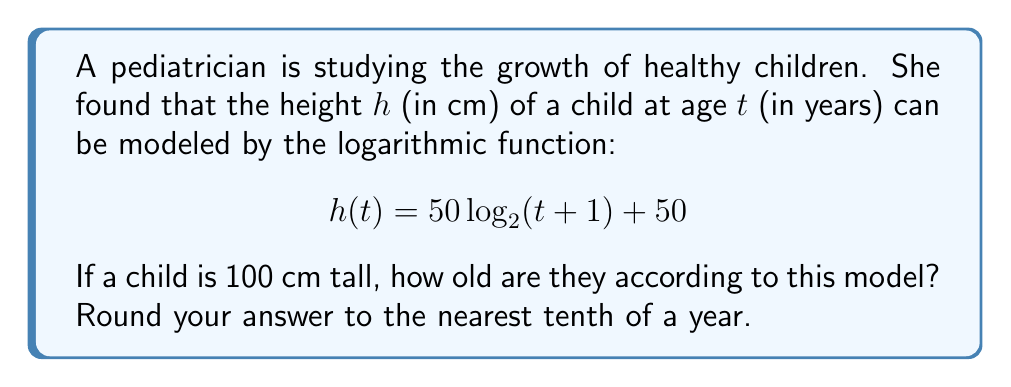Can you answer this question? Let's solve this step-by-step:

1) We're given that $h(t) = 50 \log_2(t+1) + 50$ and we want to find $t$ when $h(t) = 100$.

2) Substitute $h(t) = 100$ into the equation:
   $100 = 50 \log_2(t+1) + 50$

3) Subtract 50 from both sides:
   $50 = 50 \log_2(t+1)$

4) Divide both sides by 50:
   $1 = \log_2(t+1)$

5) To solve for $t$, we need to apply the inverse function of $\log_2$, which is $2^x$:
   $2^1 = t+1$

6) Simplify:
   $2 = t+1$

7) Subtract 1 from both sides:
   $1 = t$

Therefore, according to this model, a child is 1 year old when they are 100 cm tall.

Rounding to the nearest tenth of a year: 1.0 years.
Answer: 1.0 years 